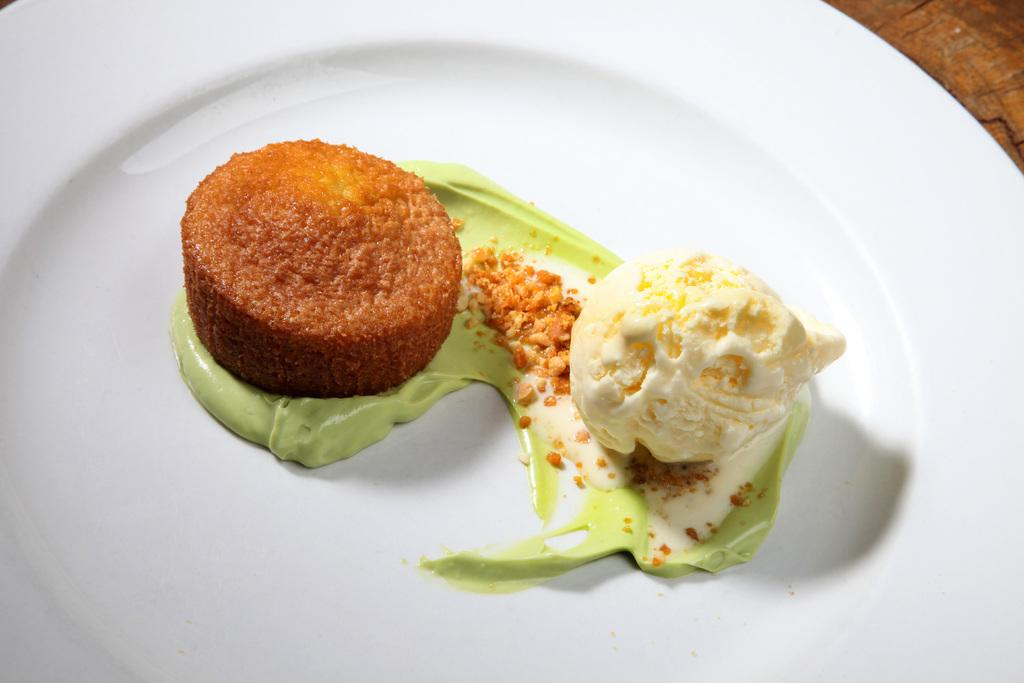What is present on the plate in the image? There is food on a white plate in the image. What colors can be seen in the food? The food has brown, green, and white colors. How many cans are visible in the image? There are no cans present in the image. What is the hour of the day depicted in the image? The provided facts do not give any information about the time of day, so it cannot be determined from the image. 